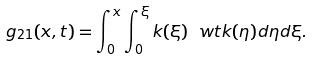<formula> <loc_0><loc_0><loc_500><loc_500>\ g _ { 2 1 } ( x , t ) = \int _ { 0 } ^ { x } \int _ { 0 } ^ { \xi } k ( \xi ) \ w t k ( \eta ) d \eta d \xi .</formula> 